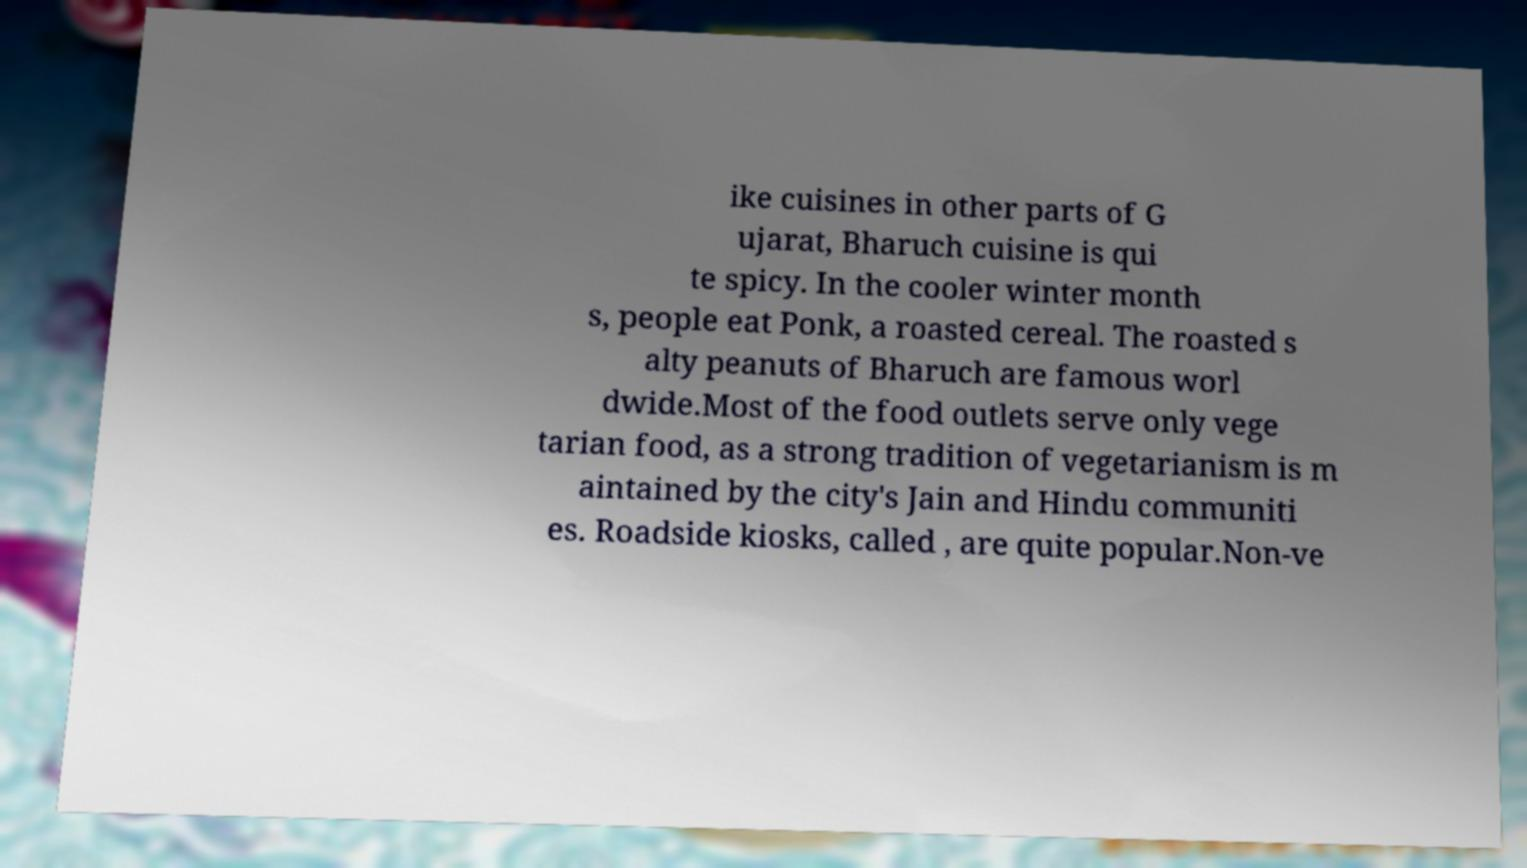For documentation purposes, I need the text within this image transcribed. Could you provide that? ike cuisines in other parts of G ujarat, Bharuch cuisine is qui te spicy. In the cooler winter month s, people eat Ponk, a roasted cereal. The roasted s alty peanuts of Bharuch are famous worl dwide.Most of the food outlets serve only vege tarian food, as a strong tradition of vegetarianism is m aintained by the city's Jain and Hindu communiti es. Roadside kiosks, called , are quite popular.Non-ve 